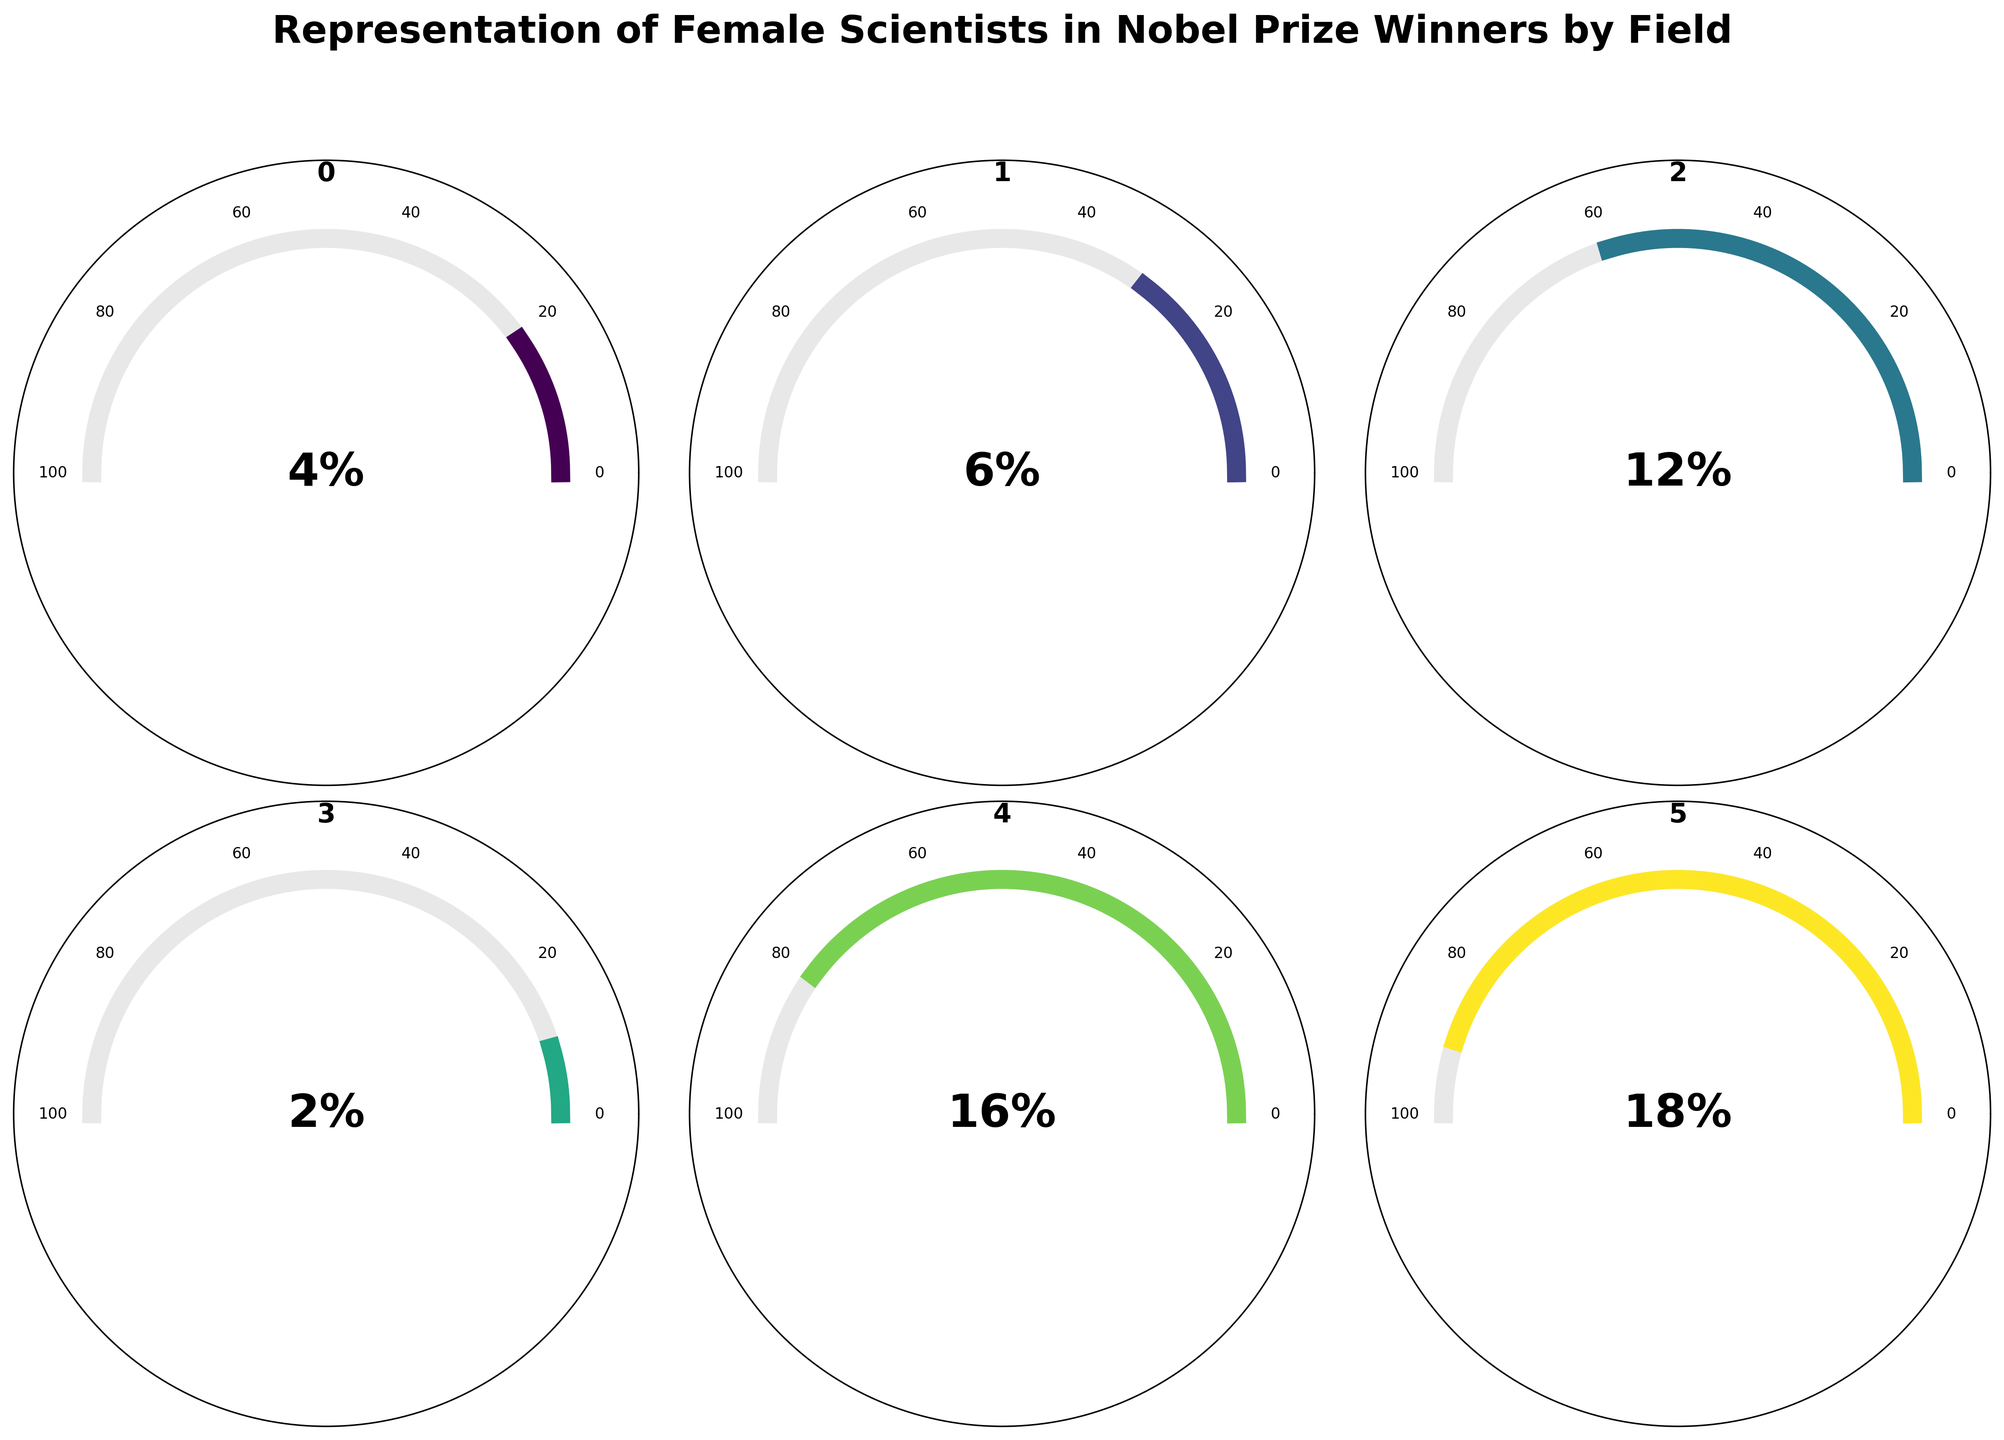What's the title of the figure? The title is typically found at the top of the figure and it reads "Representation of Female Scientists in Nobel Prize Winners by Field."
Answer: Representation of Female Scientists in Nobel Prize Winners by Field How many subplots are in the figure? There are six subplots arranged in a 2 by 3 grid. This can be determined by counting the individual circular gauge charts.
Answer: 6 Which field has the highest percentage of female Nobel Prize winners? To identify the highest percentage, compare the percentages in the center of each gauge chart. The field with "18%" labeled is the highest.
Answer: Peace What is the percentage of female Nobel Prize winners in Physics? Locate the gauge chart for Physics and read the percentage label in the center, which is shown as "4%."
Answer: 4% Compare the percentage of female Nobel winners in Economics and Chemistry. Which one is higher? By comparing the percentages within the gauges labeled "Economics" and "Chemistry," Economics has "2%" and Chemistry has "6%". Therefore, Chemistry has a higher percentage.
Answer: Chemistry What's the difference in percentage between female Nobel Prize winners in Literature and Physiology or Medicine? Literature has "16%" and Physiology or Medicine has "12%." Subtract 12% from 16% to find the difference: 16% - 12% = 4%.
Answer: 4% Is the percentage of female Nobel Prize winners in Peace more than double that in Chemistry? The Peace field shows "18%" and Chemistry shows "6%". Doubling the percentage for Chemistry gives 6% * 2 = 12%. Since 18% is more than 12%, the statement is true.
Answer: Yes What is the average percentage of female representation across all fields presented? To find the average, sum the percentages: 4% + 6% + 12% + 2% + 16% + 18% = 58%. Then divide by the number of fields (6): 58% / 6 ≈ 9.67%.
Answer: 9.67% Which fields have a female Nobel Prize winner representation below 10%? By examining the percentages, Physics (4%), Chemistry (6%), and Economics (2%) are all below 10%.
Answer: Physics, Chemistry, Economics What's the median percentage of female representation across the fields? Arrange the percentages in ascending order: 2%, 4%, 6%, 12%, 16%, 18%. The median is the average of the middle two values: (6% + 12%) / 2 = 9%.
Answer: 9% 